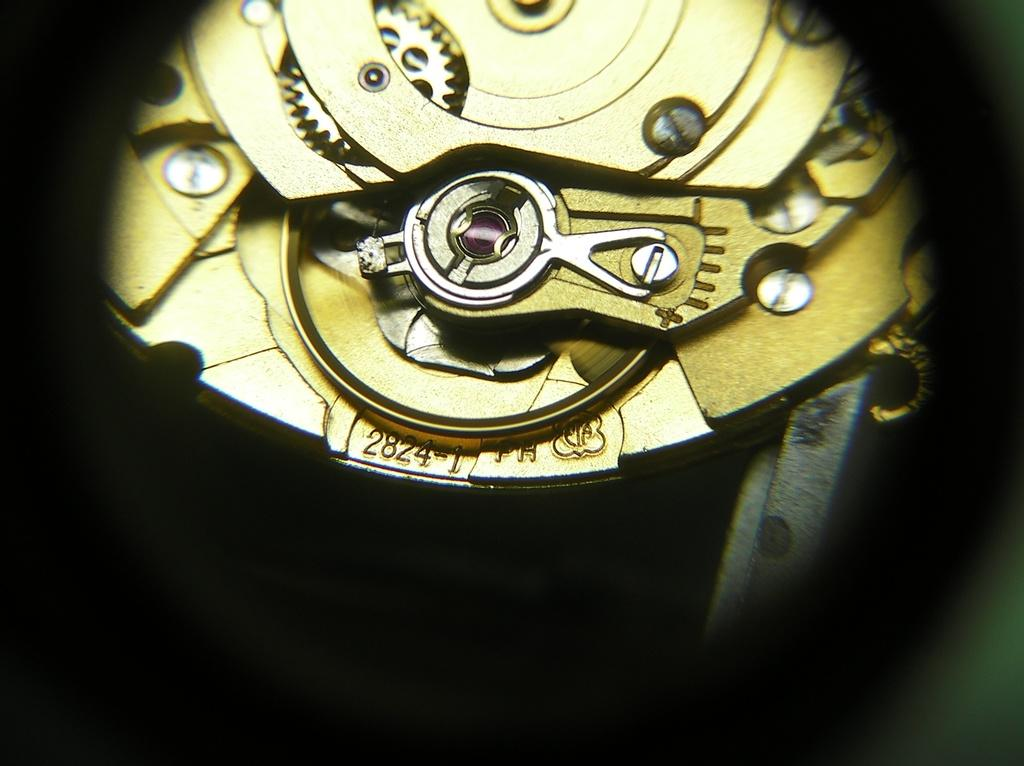Provide a one-sentence caption for the provided image. The workings of a watch identified as 2824-1. 